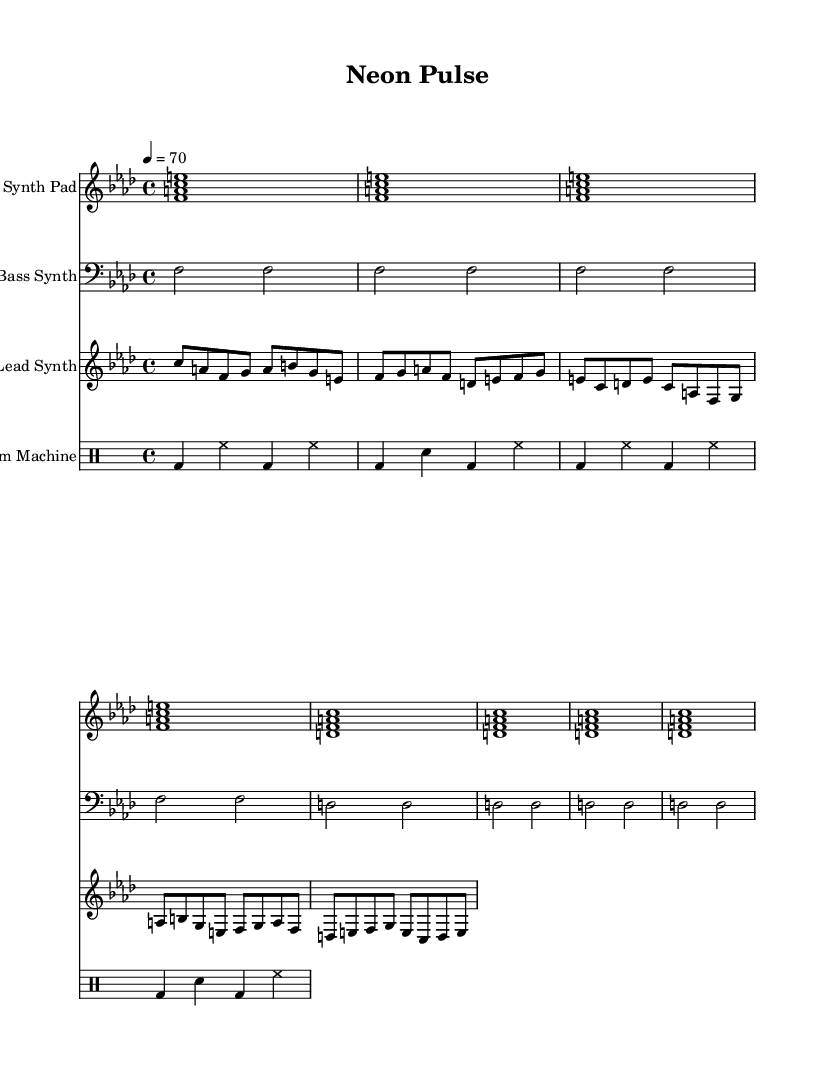What is the key signature of this music? The key signature indicated in the sheet music is F minor, which contains four flats: B♭, E♭, A♭, and D♭.
Answer: F minor What is the time signature of this music? The time signature shown in the sheet music is 4/4, which means there are four beats in each measure, and the quarter note gets one beat.
Answer: 4/4 What is the tempo marking for this piece? The tempo marking provided in the music sheet indicates a quarter note equals 70 beats per minute, which is a moderate tempo.
Answer: 70 How many measures are in the lead synth part? By reviewing the lead synth notations, there are a total of eight measures present in the part, each measure corresponds to a segment of music as shown in the notation.
Answer: 8 Which instrument plays the bass synth part? The bass synth part is labeled under a staff marked "Bass Synth," indicating it is played by a synthesizer designed to produce low frequencies or bass sounds.
Answer: Bass Synth What type of rhythm is predominantly used in the drum machine part? The drum machine part primarily uses a combination of bass drum and hi-hat patterns, creating a steady groove typical of electronic music, alternating between bass drum hits and closed hi-hat sounds.
Answer: Bass drum and hi-hat What is the overall mood conveyed by the synth pad section? The synth pad section, characterized by sustained chords, creates an ambient and atmospheric feel, often associated with urban nightlife, suggesting a chill yet vibrant mood as found in city soundscapes.
Answer: Ambient 